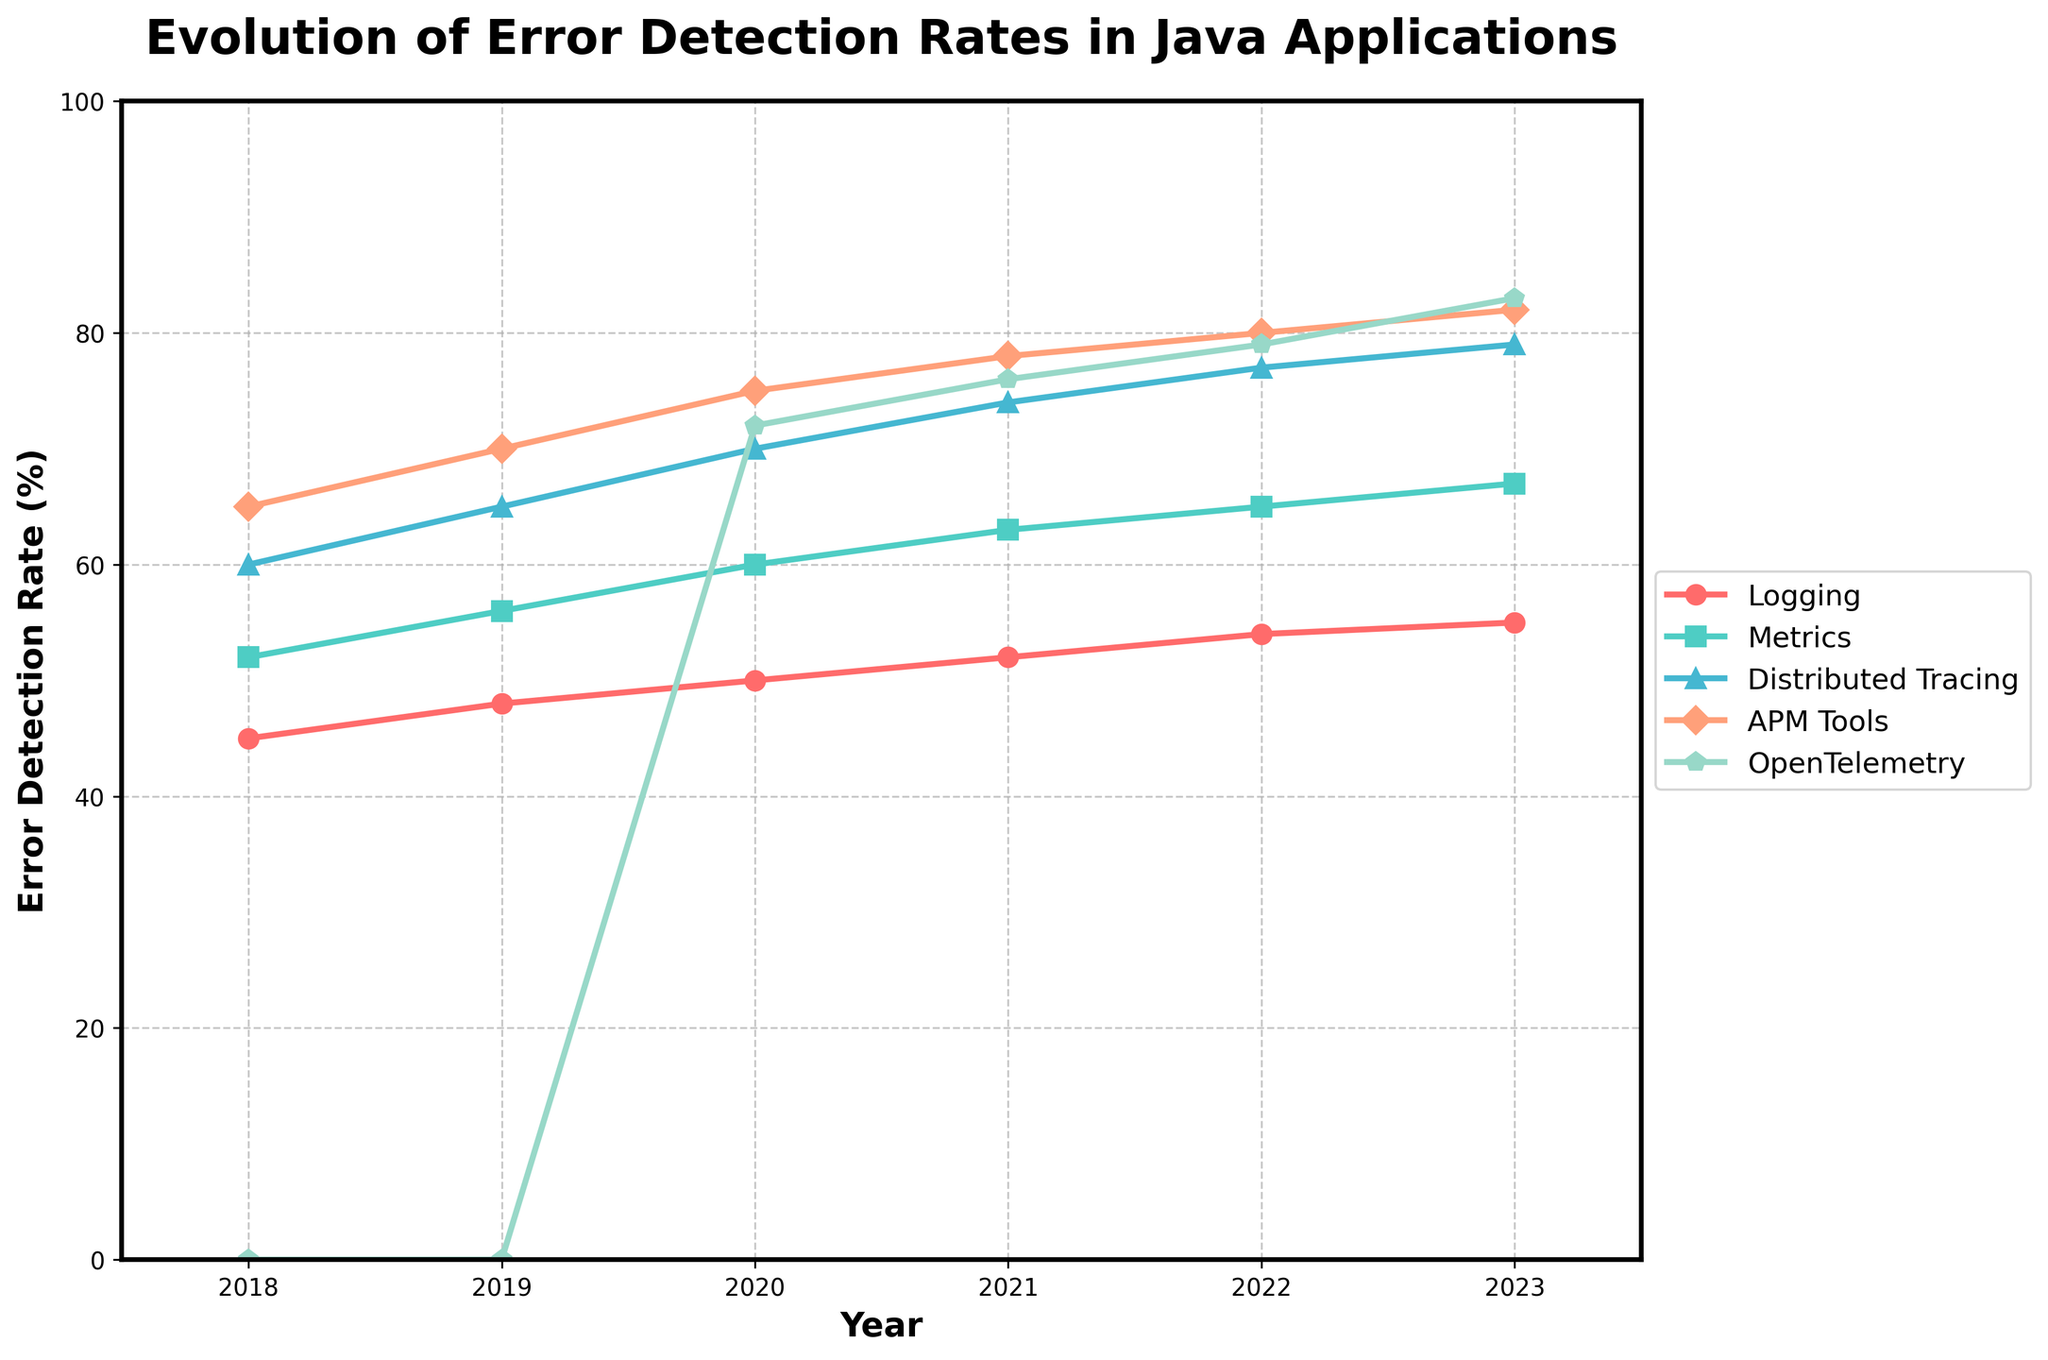What's the general trend of error detection rates for APM Tools from 2018 to 2023? The error detection rate for APM Tools shows a consistently increasing trend every year from 65% in 2018 to 82% in 2023.
Answer: Increasing Which observability approach had the highest error detection rate in 2020? In 2020, APM Tools had the highest error detection rate at 75%.
Answer: APM Tools Comparing Logging and Distributed Tracing in 2021, which had a higher error detection rate and by how much? In 2021, Distributed Tracing had an error detection rate of 74%, while Logging had 52%. The difference is 74% - 52% = 22%.
Answer: Distributed Tracing by 22% What was the error detection rate for OpenTelemetry in its first recorded year? OpenTelemetry's first recorded year is 2020, with an error detection rate of 72%.
Answer: 72% Has any observability approach achieved an error detection rate over 80% by 2023? If so, which ones? By 2023, both APM Tools and OpenTelemetry have error detection rates over 80% with 82% and 83%, respectively.
Answer: APM Tools and OpenTelemetry What's the difference in error detection rates between Metrics and OpenTelemetry in 2023? In 2023, Metrics has an error detection rate of 67%, and OpenTelemetry has 83%. The difference is 83% - 67% = 16%.
Answer: 16% Which observability approach showed the most significant improvement in error detection rate from 2020 to 2023? OpenTelemetry showed the most significant improvement, increasing from 72% in 2020 to 83% in 2023, which is an 11% increase.
Answer: OpenTelemetry What is the average error detection rate of all approaches except OpenTelemetry in 2022? The error detection rates for 2022 are Logging: 54%, Metrics: 65%, Distributed Tracing: 77%, APM Tools: 80%. The average is (54 + 65 + 77 + 80) / 4 = 276 / 4 = 69%.
Answer: 69% Between Logging and Metrics, which has consistently had a higher error detection rate from 2018 to 2023? Metrics has consistently had a higher error detection rate compared to Logging from 2018 to 2023 in all given years.
Answer: Metrics What's the increase in error detection rate for Distributed Tracing from 2018 to 2023? In 2018, Distributed Tracing had an error detection rate of 60%, and in 2023 it had 79%. The increase is 79% - 60% = 19%.
Answer: 19% 